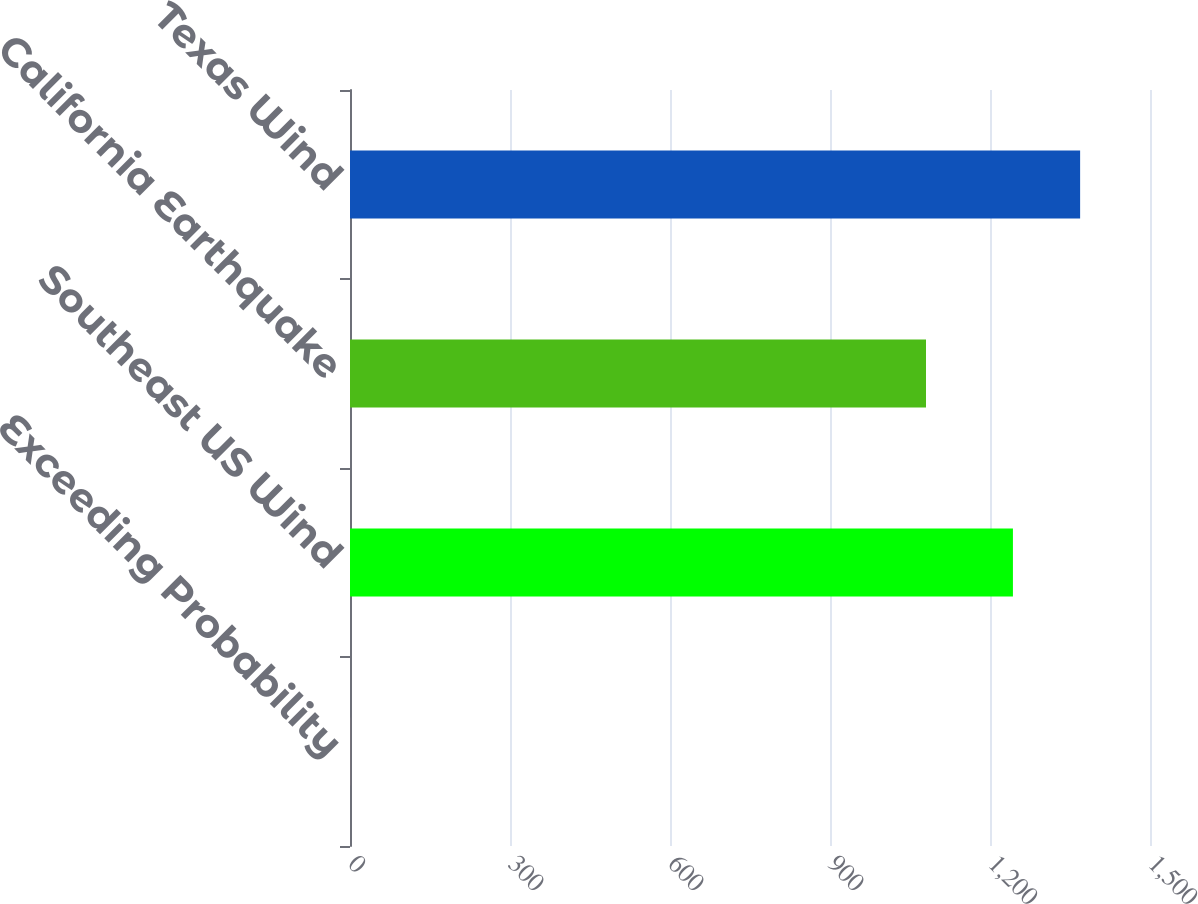Convert chart to OTSL. <chart><loc_0><loc_0><loc_500><loc_500><bar_chart><fcel>Exceeding Probability<fcel>Southeast US Wind<fcel>California Earthquake<fcel>Texas Wind<nl><fcel>0.2<fcel>1243<fcel>1080<fcel>1368.98<nl></chart> 